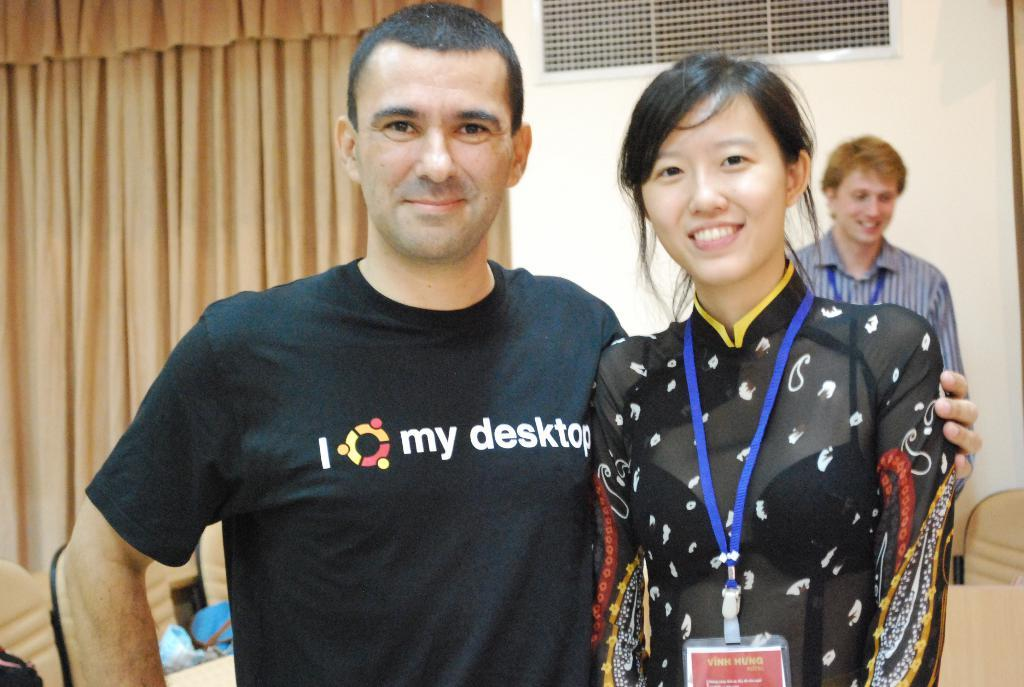<image>
Create a compact narrative representing the image presented. A man is wearing a black shirt that says my desktop on it. 